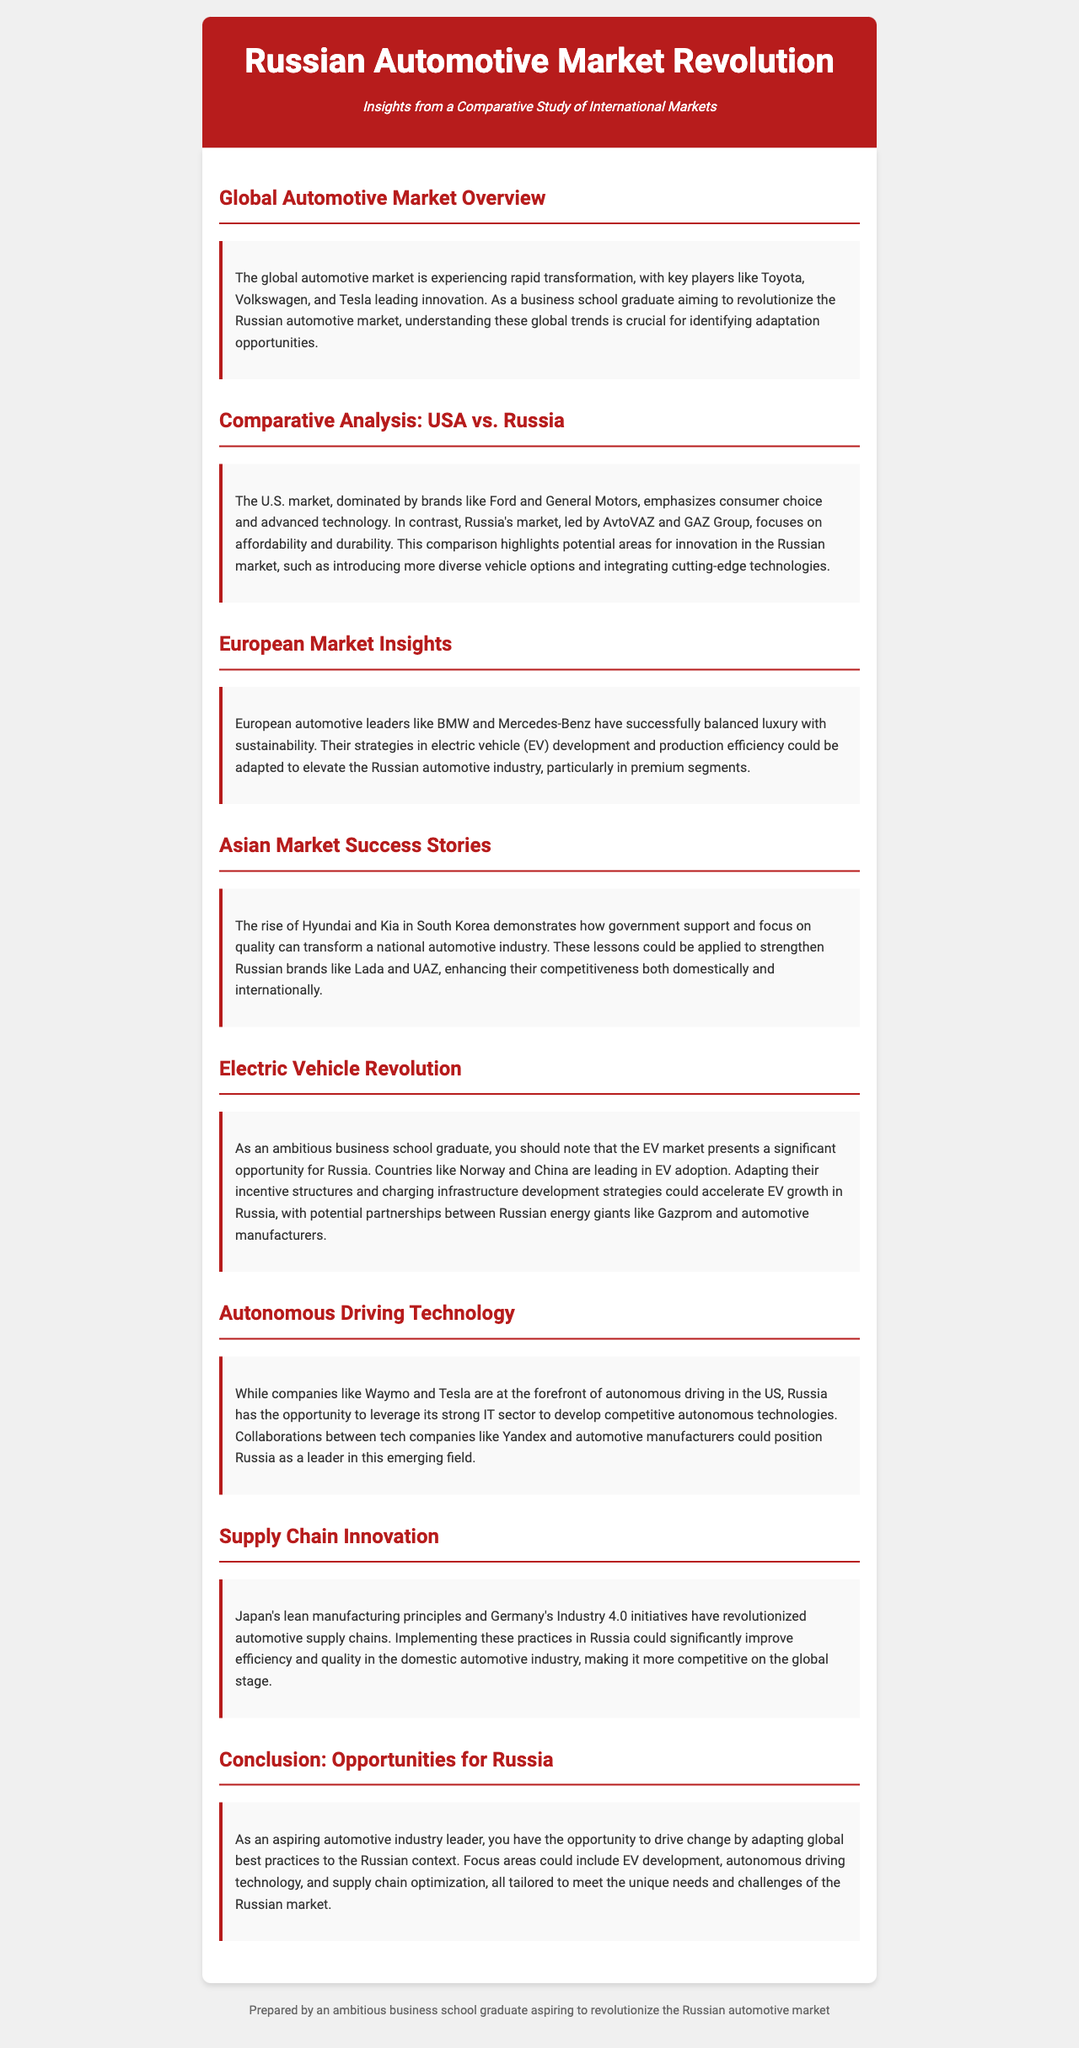What is the title of the newsletter? The title is presented prominently at the top of the document, indicating the focus on the Russian automotive market.
Answer: Russian Automotive Market Revolution Who are the key players mentioned in the global automotive market? Toyota, Volkswagen, and Tesla are highlighted as leaders in innovation in the global market.
Answer: Toyota, Volkswagen, and Tesla Which two brands dominate the U.S. automotive market? The document specifically mentions Ford and General Motors as dominant brands in the U.S. market.
Answer: Ford and General Motors What is a focus area for the Russian market based on European insights? The newsletter notes that luxury and sustainability are key strategies in the European market that could be adapted in Russia.
Answer: Luxury and sustainability What successful automotive companies are mentioned in the Asian market section? Hyundai and Kia are recognized for their rise in the South Korean automotive industry.
Answer: Hyundai and Kia What emerging technology is highlighted for its opportunity in Russia? The document emphasizes the potential for developing autonomous driving technology in Russia.
Answer: Autonomous driving technology What principles from Japan and Germany could improve the Russian automotive supply chain? The newsletter refers to lean manufacturing principles from Japan and Industry 4.0 initiatives from Germany as potential improvements.
Answer: Lean manufacturing principles and Industry 4.0 initiatives What major opportunity does the electric vehicle market present for Russia? The document indicates that adapting incentive structures and charging infrastructure could significantly accelerate EV growth in Russia.
Answer: EV growth What type of technology does the newsletter suggest collaborating on in Russia? The document suggests collaboration between tech companies and automotive manufacturers to develop competitive technologies.
Answer: Competitive technologies 